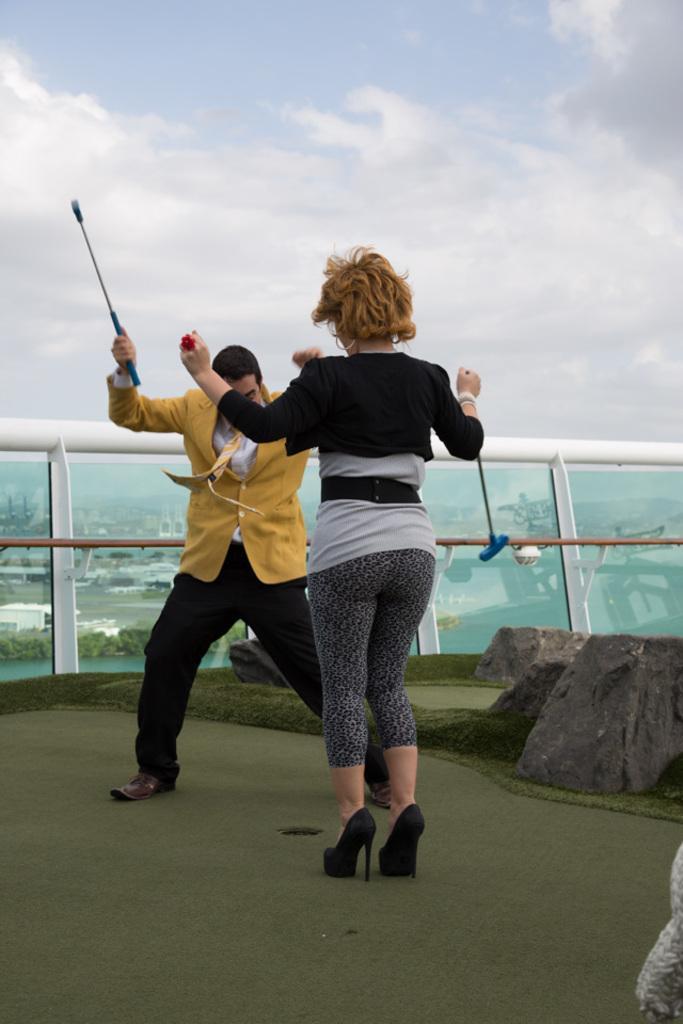Could you give a brief overview of what you see in this image? In this picture we can see there are two people standing on the path and a man is holding a stick. On the right side of the people there are rocks and behind the people there is the glass fence. Behind the glass fence there are trees, houses and the sky. 